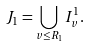Convert formula to latex. <formula><loc_0><loc_0><loc_500><loc_500>J _ { 1 } = \bigcup _ { v \leq R _ { 1 } } I ^ { 1 } _ { v } .</formula> 